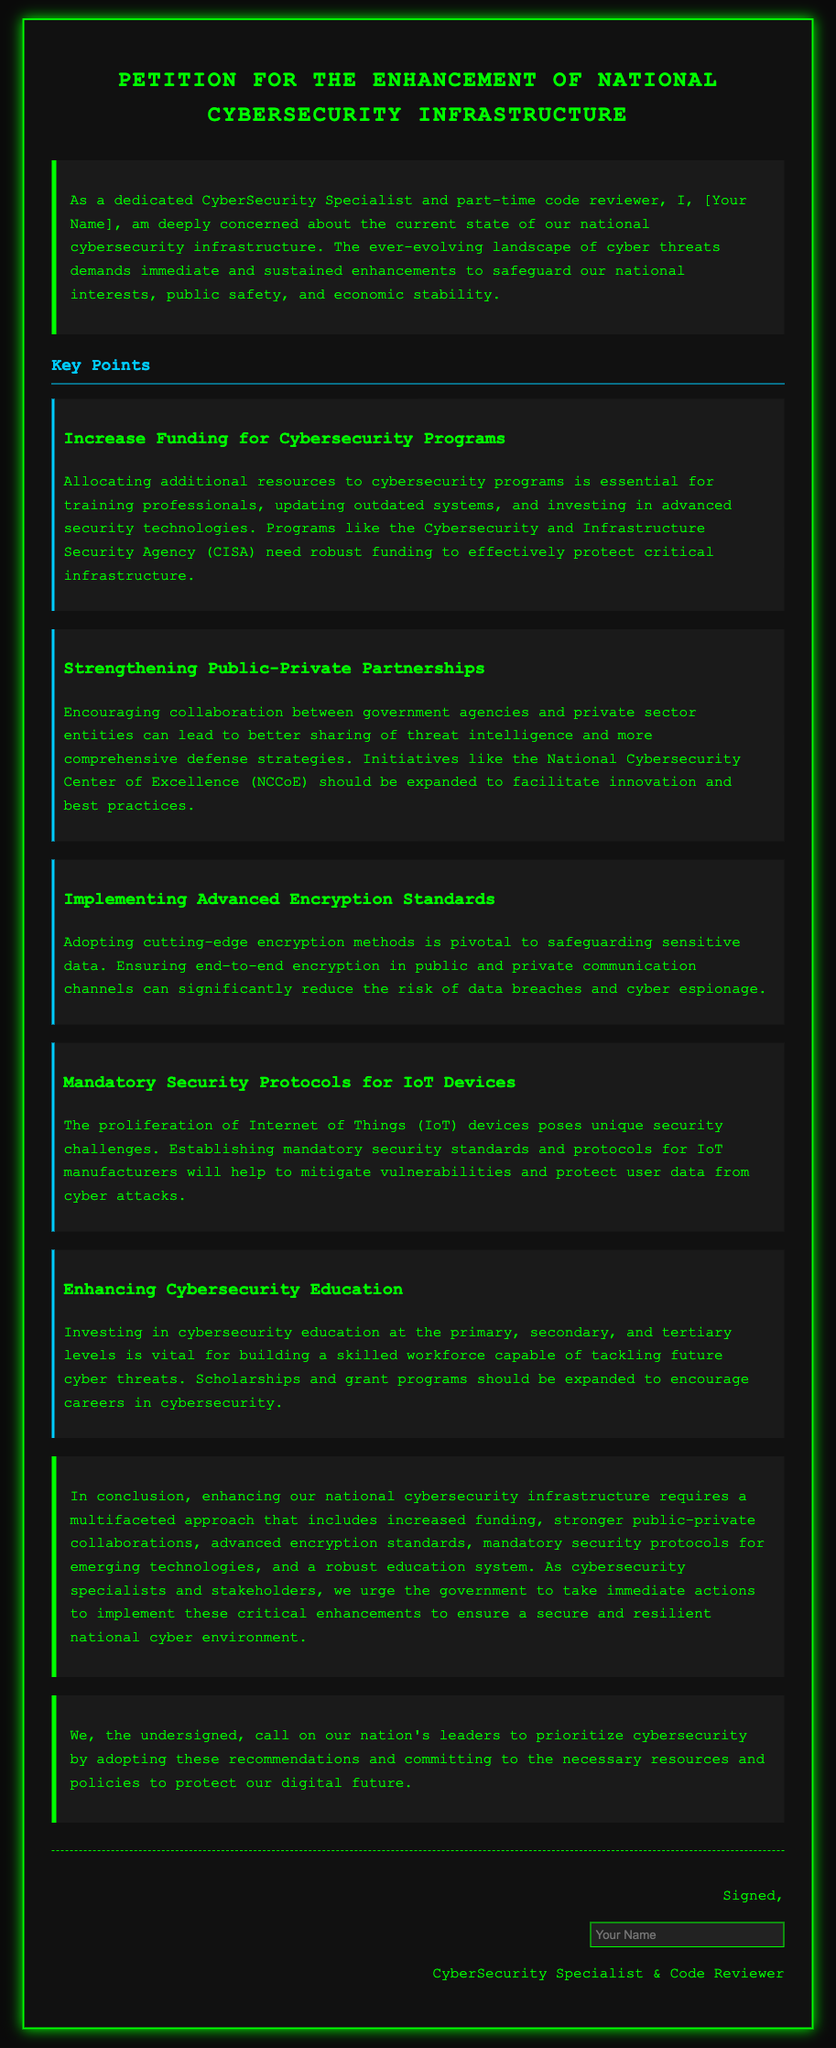what is the title of the petition? The title of the petition is specified at the top of the document, signaling the main focus of the document.
Answer: Petition for the Enhancement of National Cybersecurity Infrastructure who is the primary author of the petition? The author’s name is mentioned in the introduction section, denoting the individual responsible for the petition.
Answer: [Your Name] what is one key point mentioned about funding? One of the key points discusses the necessity for increased funding to enhance cybersecurity initiatives as indicated in the document.
Answer: Increase Funding for Cybersecurity Programs which agency's funding is specifically mentioned? The document mentions the specific agency that requires additional funding to protect critical infrastructure effectively.
Answer: Cybersecurity and Infrastructure Security Agency (CISA) how many key points are listed in the petition? The total number of key points can be found by counting them in the key points section of the document.
Answer: Five what is one recommendation regarding IoT devices? The document includes a recommendation highlighting the importance of standards for IoT devices, which is mentioned in the key points section.
Answer: Mandatory Security Protocols for IoT Devices what is the overall conclusion drawn in the petition? The conclusion summarizes the main enhancements needed for national cybersecurity and is encapsulated in a concluding paragraph.
Answer: enhancing our national cybersecurity infrastructure requires a multifaceted approach what does the call-to-action emphasize? The call-to-action section stresses the urgency of prioritizing cybersecurity in national policy, reflecting the petition's intentions.
Answer: prioritize cybersecurity by adopting these recommendations 